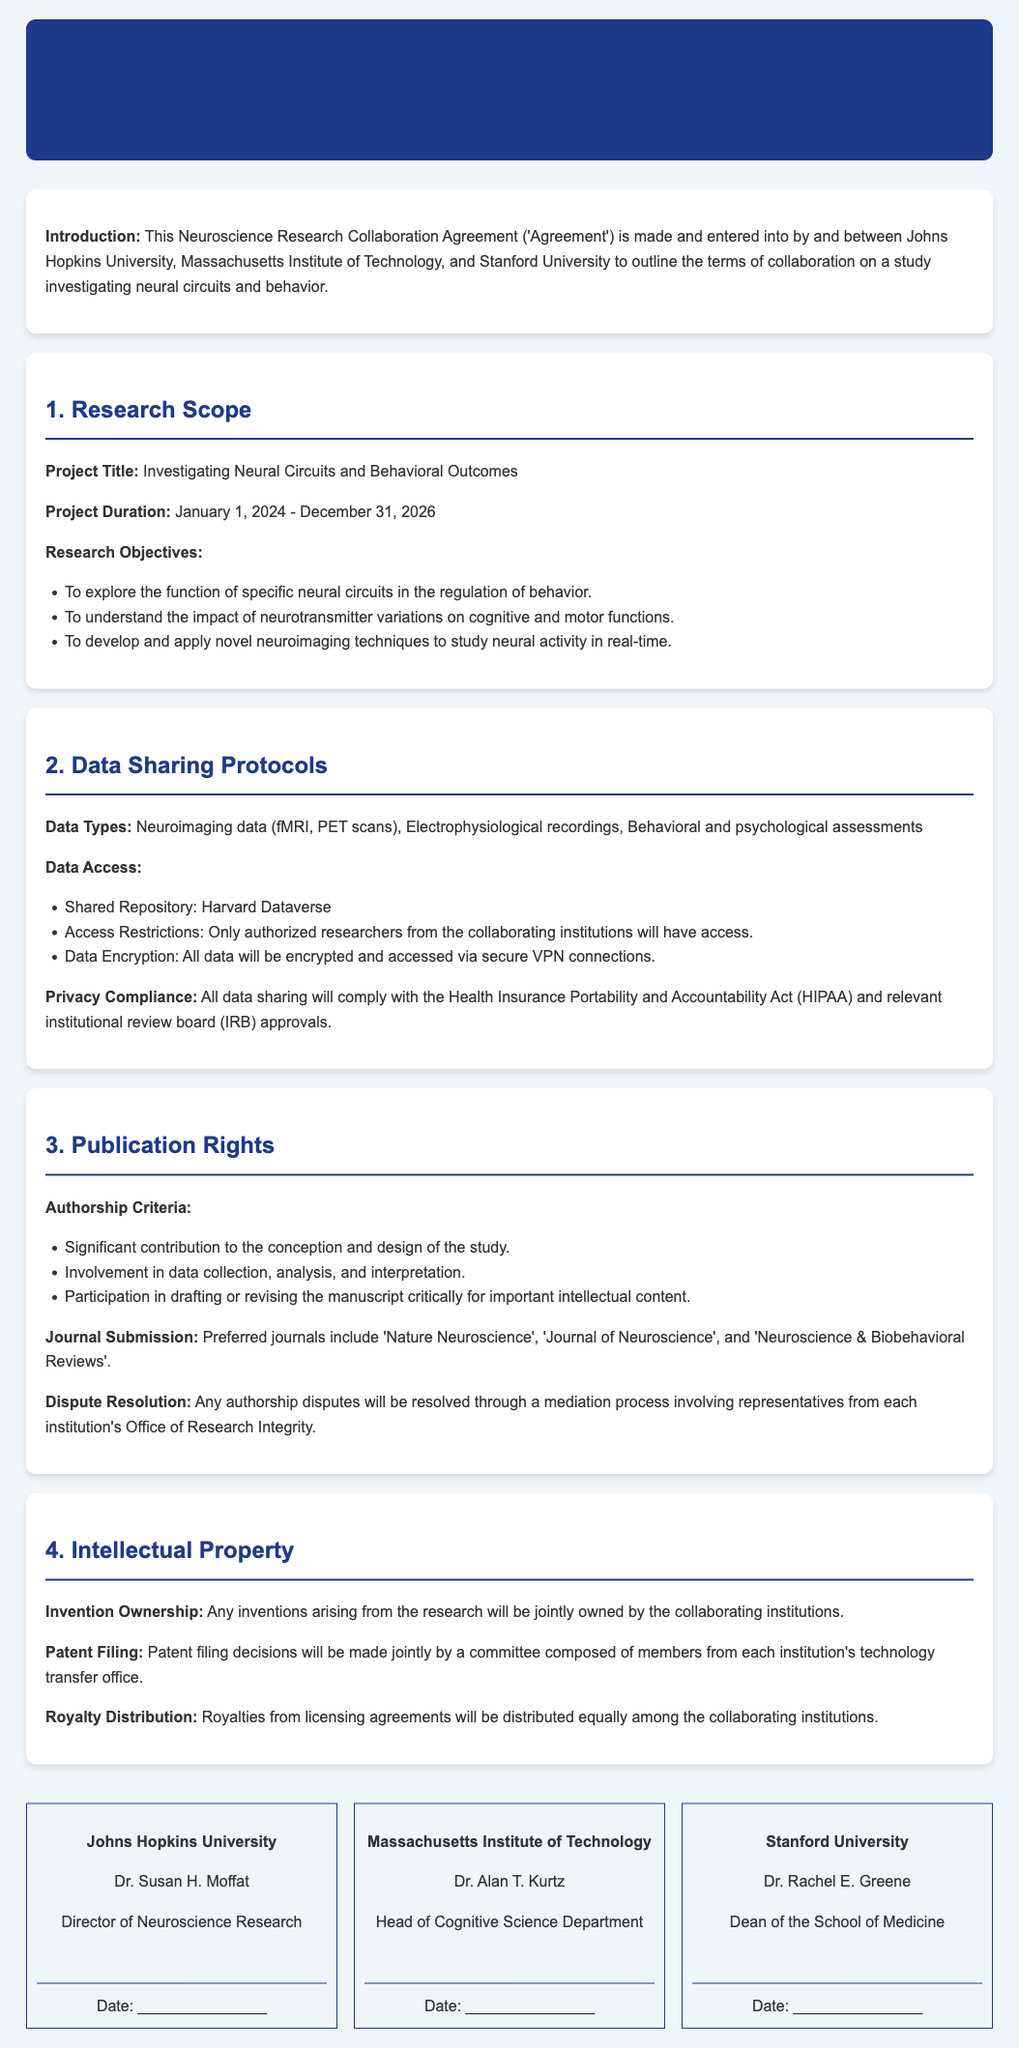What is the project title? The project title is stated in the research scope section of the document.
Answer: Investigating Neural Circuits and Behavioral Outcomes What is the project duration? The project duration is specified in the research scope section as the start and end date.
Answer: January 1, 2024 - December 31, 2026 Which institutions are involved in the collaboration? The institutions involved are listed in the introduction of the document.
Answer: Johns Hopkins University, Massachusetts Institute of Technology, and Stanford University Where will the shared data repository be located? The location of the shared data repository is mentioned in the data sharing protocols section.
Answer: Harvard Dataverse What are the preferred journals for submission? Preferred journals for publication are listed under the publication rights section.
Answer: Nature Neuroscience, Journal of Neuroscience, and Neuroscience & Biobehavioral Reviews How will royalties be distributed? The method of royalty distribution is specified in the intellectual property section of the document.
Answer: Equally among the collaborating institutions Who is the Director of Neuroscience Research at Johns Hopkins University? The document specifies the person holding this position in the signature section.
Answer: Dr. Susan H. Moffat What is required for authorship according to the agreement? The criteria for authorship are provided in the publication rights section of the document.
Answer: Significant contribution to the conception and design of the study What will be the compliance requirements for data sharing? Compliance requirements are mentioned in the data sharing protocols section of the document.
Answer: HIPAA and relevant IRB approvals 